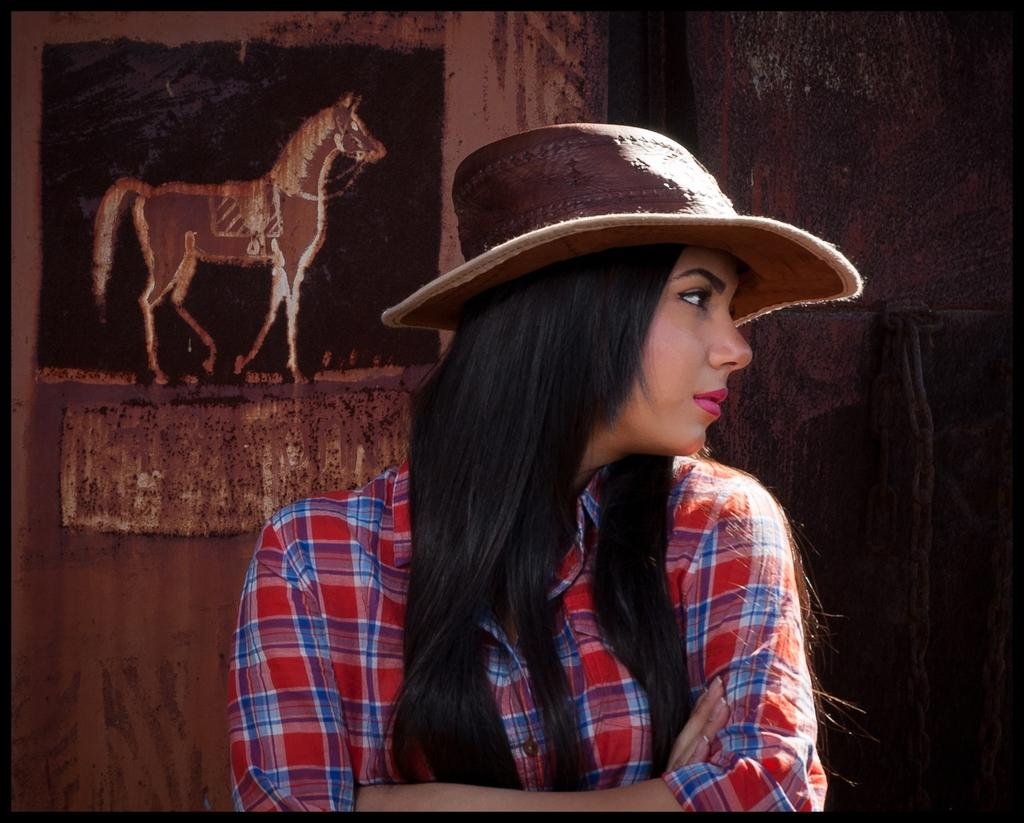Who is the main subject in the image? There is a girl standing in the center of the image. What is the girl wearing on her head? The girl is wearing a hat. What can be seen in the background of the image? There is a wall in the background of the image. What is depicted on the wall in the background? There is a painting on the wall in the background. What type of suit is the girl wearing in the image? The girl is not wearing a suit in the image; she is wearing a hat. How many chin-ups can the girl perform in the image? There is no indication of the girl performing chin-ups in the image. 